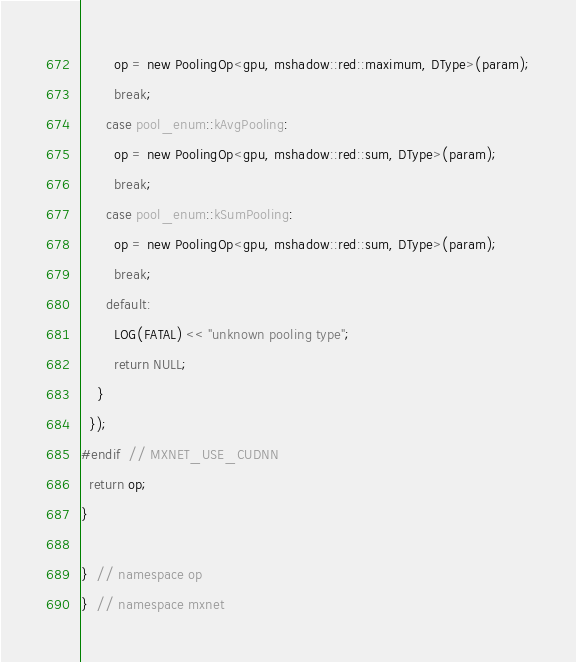Convert code to text. <code><loc_0><loc_0><loc_500><loc_500><_Cuda_>        op = new PoolingOp<gpu, mshadow::red::maximum, DType>(param);
        break;
      case pool_enum::kAvgPooling:
        op = new PoolingOp<gpu, mshadow::red::sum, DType>(param);
        break;
      case pool_enum::kSumPooling:
        op = new PoolingOp<gpu, mshadow::red::sum, DType>(param);
        break;
      default:
        LOG(FATAL) << "unknown pooling type";
        return NULL;
    }
  });
#endif  // MXNET_USE_CUDNN
  return op;
}

}  // namespace op
}  // namespace mxnet

</code> 